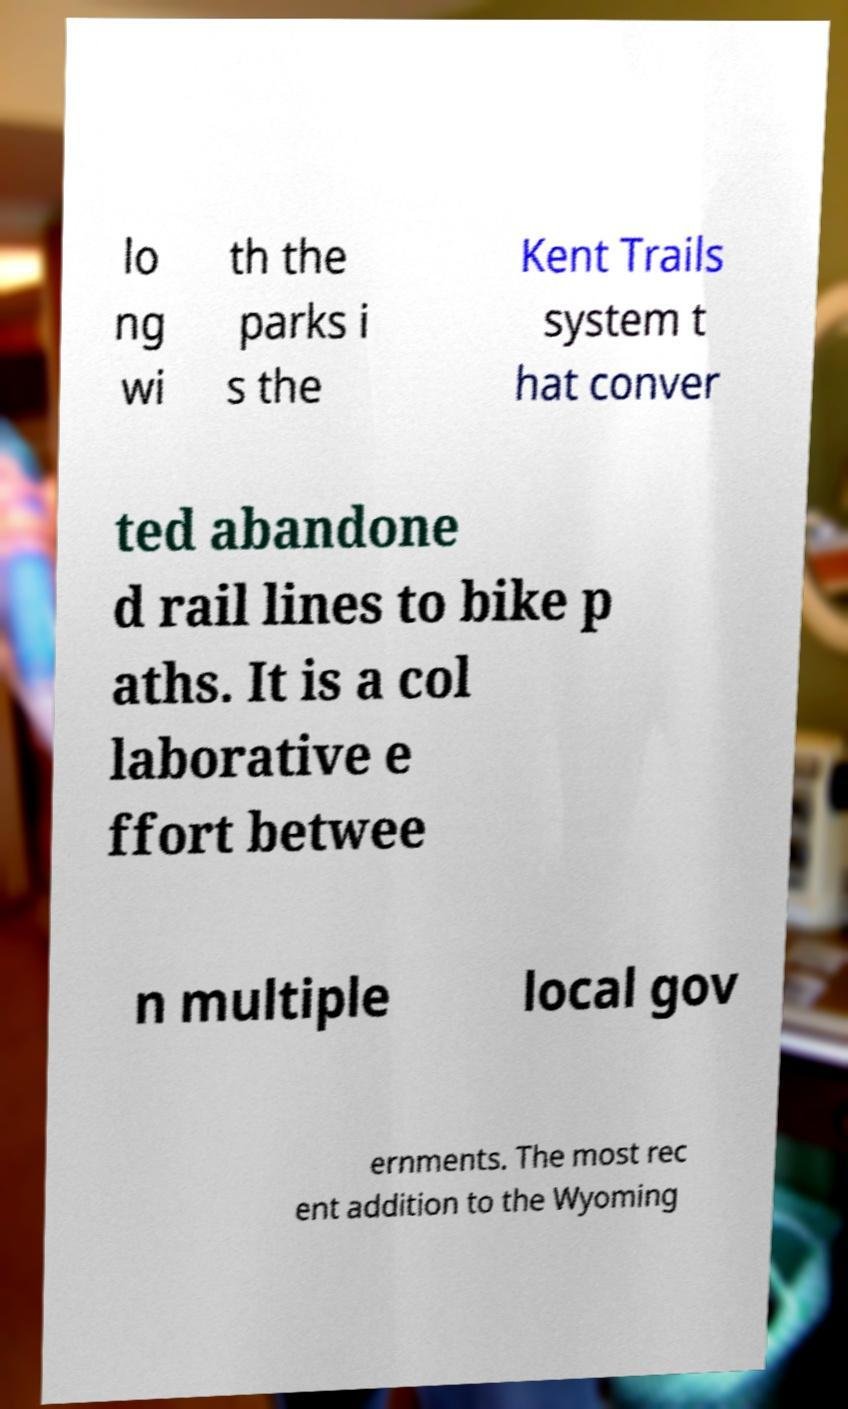I need the written content from this picture converted into text. Can you do that? lo ng wi th the parks i s the Kent Trails system t hat conver ted abandone d rail lines to bike p aths. It is a col laborative e ffort betwee n multiple local gov ernments. The most rec ent addition to the Wyoming 